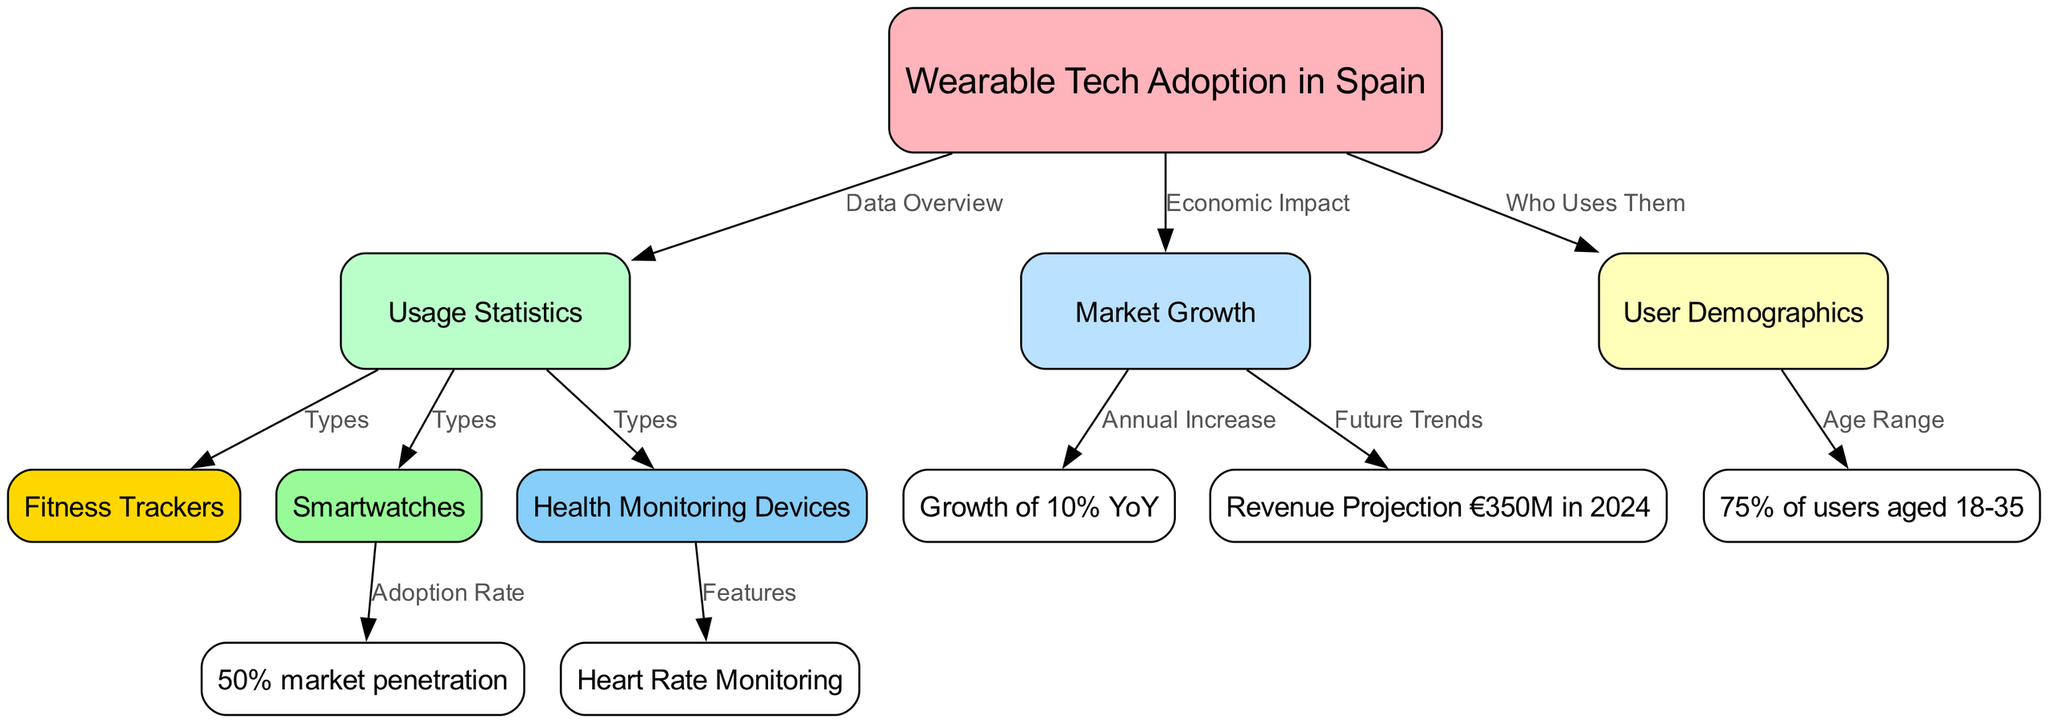What is the primary focus of the diagram? The primary focus of the diagram is "Wearable Tech Adoption in Spain," which is represented as the central node. The surrounding nodes provide details about usage statistics, market growth, and user demographics related to wearable tech.
Answer: Wearable Tech Adoption in Spain What age group makes up 75% of users? In the diagram, the node representing the demographics states that "75% of users aged 18-35" use wearable tech.
Answer: 18-35 What type of wearable technology has a 50% market penetration? The diagram indicates that smartwatches specifically have an adoption rate of "50% market penetration," as shown in the connection from the smartwatches node.
Answer: Smartwatches What is the projected revenue for the market in 2024? According to the diagram, the revenue projection for the wearable tech market in Spain is indicated as "€350M in 2024."
Answer: €350M in 2024 What is the annual growth rate of the wearable tech market? The diagram shows the annual increase in market growth as "10% YoY," indicating a yearly growth rate of 10%.
Answer: 10% YoY How many nodes are related to types of wearable technology? The diagram illustrates three distinct types of wearable technology—fitness trackers, smartwatches, and health monitoring devices—connected to the usage statistics node. Hence, there are three nodes related to types.
Answer: 3 What feature is associated with health monitoring devices? The edge connecting health monitoring devices highlights "Heart Rate Monitoring" as a key feature associated with them.
Answer: Heart Rate Monitoring Which aspect of the diagram discusses market growth? The node labeled "Market Growth" addresses the economic impact and trends related to the overall growth of wearable technology in Spain.
Answer: Market Growth What is the relationship between "Market Growth" and "Future Trends"? The diagram depicts a direct connection where "Future Trends" is associated with the market growth, indicating that growth trends will influence future projections.
Answer: Future Trends 